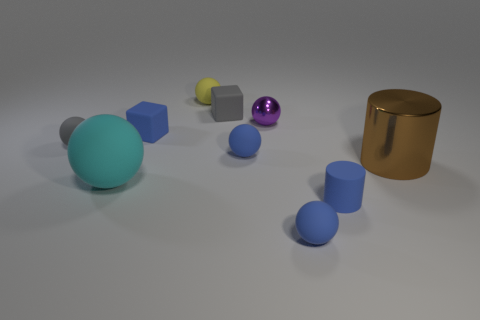How many other objects are the same color as the small cylinder?
Your answer should be compact. 3. What is the color of the metallic thing in front of the gray thing that is in front of the small gray object that is to the right of the small yellow rubber ball?
Make the answer very short. Brown. Are there an equal number of brown objects behind the tiny yellow rubber thing and small yellow matte cylinders?
Give a very brief answer. Yes. Is the size of the gray object that is on the right side of the cyan matte ball the same as the big sphere?
Provide a succinct answer. No. What number of yellow balls are there?
Offer a very short reply. 1. What number of big things are right of the cyan thing and to the left of the brown thing?
Your answer should be compact. 0. Is there a gray ball that has the same material as the small cylinder?
Give a very brief answer. Yes. What is the material of the blue thing that is behind the small gray rubber object on the left side of the yellow rubber sphere?
Provide a succinct answer. Rubber. Are there an equal number of gray cubes that are to the right of the small purple metal sphere and matte spheres that are on the right side of the yellow thing?
Your answer should be compact. No. Does the small yellow thing have the same shape as the large matte object?
Keep it short and to the point. Yes. 